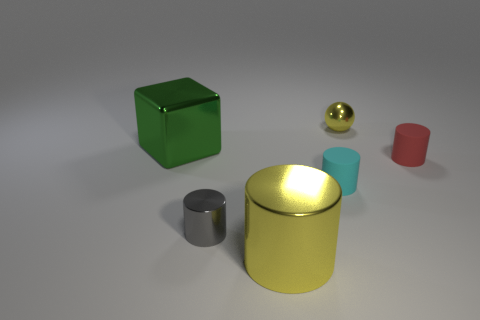Subtract all purple cylinders. Subtract all cyan spheres. How many cylinders are left? 4 Add 2 cyan matte cylinders. How many objects exist? 8 Subtract all cubes. How many objects are left? 5 Subtract 0 yellow blocks. How many objects are left? 6 Subtract all red metallic balls. Subtract all tiny metallic balls. How many objects are left? 5 Add 2 large yellow metal cylinders. How many large yellow metal cylinders are left? 3 Add 3 big red matte blocks. How many big red matte blocks exist? 3 